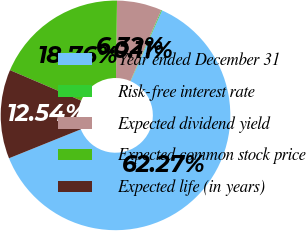Convert chart. <chart><loc_0><loc_0><loc_500><loc_500><pie_chart><fcel>Year ended December 31<fcel>Risk-free interest rate<fcel>Expected dividend yield<fcel>Expected common stock price<fcel>Expected life (in years)<nl><fcel>62.27%<fcel>0.11%<fcel>6.32%<fcel>18.76%<fcel>12.54%<nl></chart> 